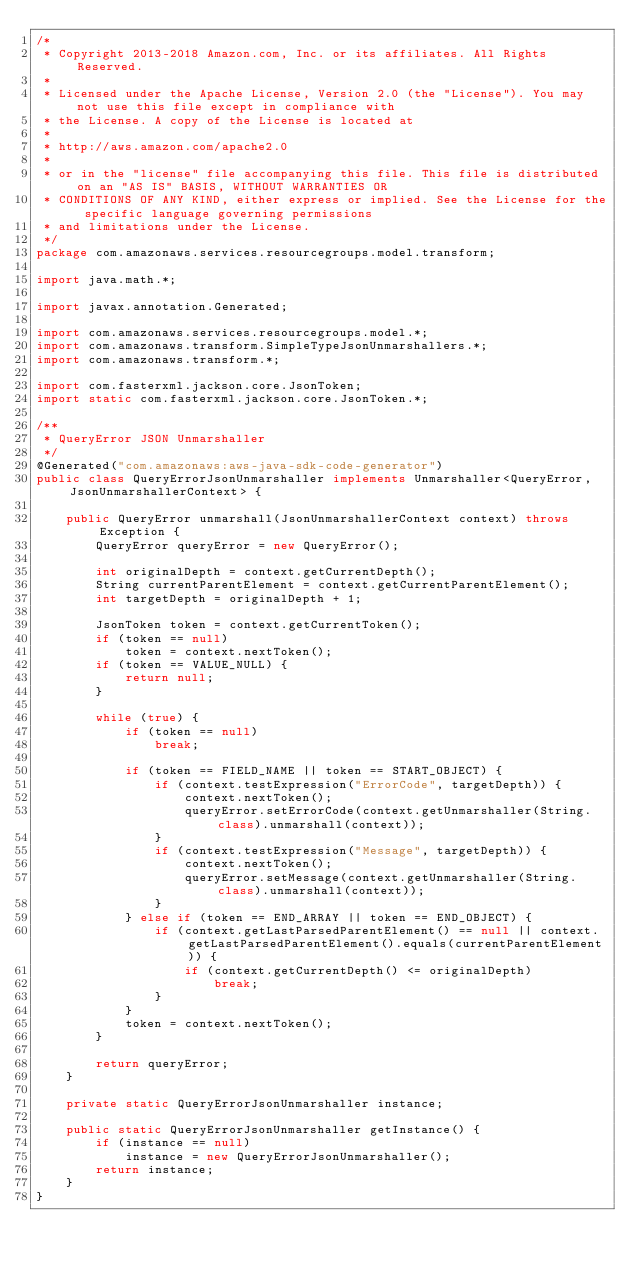Convert code to text. <code><loc_0><loc_0><loc_500><loc_500><_Java_>/*
 * Copyright 2013-2018 Amazon.com, Inc. or its affiliates. All Rights Reserved.
 * 
 * Licensed under the Apache License, Version 2.0 (the "License"). You may not use this file except in compliance with
 * the License. A copy of the License is located at
 * 
 * http://aws.amazon.com/apache2.0
 * 
 * or in the "license" file accompanying this file. This file is distributed on an "AS IS" BASIS, WITHOUT WARRANTIES OR
 * CONDITIONS OF ANY KIND, either express or implied. See the License for the specific language governing permissions
 * and limitations under the License.
 */
package com.amazonaws.services.resourcegroups.model.transform;

import java.math.*;

import javax.annotation.Generated;

import com.amazonaws.services.resourcegroups.model.*;
import com.amazonaws.transform.SimpleTypeJsonUnmarshallers.*;
import com.amazonaws.transform.*;

import com.fasterxml.jackson.core.JsonToken;
import static com.fasterxml.jackson.core.JsonToken.*;

/**
 * QueryError JSON Unmarshaller
 */
@Generated("com.amazonaws:aws-java-sdk-code-generator")
public class QueryErrorJsonUnmarshaller implements Unmarshaller<QueryError, JsonUnmarshallerContext> {

    public QueryError unmarshall(JsonUnmarshallerContext context) throws Exception {
        QueryError queryError = new QueryError();

        int originalDepth = context.getCurrentDepth();
        String currentParentElement = context.getCurrentParentElement();
        int targetDepth = originalDepth + 1;

        JsonToken token = context.getCurrentToken();
        if (token == null)
            token = context.nextToken();
        if (token == VALUE_NULL) {
            return null;
        }

        while (true) {
            if (token == null)
                break;

            if (token == FIELD_NAME || token == START_OBJECT) {
                if (context.testExpression("ErrorCode", targetDepth)) {
                    context.nextToken();
                    queryError.setErrorCode(context.getUnmarshaller(String.class).unmarshall(context));
                }
                if (context.testExpression("Message", targetDepth)) {
                    context.nextToken();
                    queryError.setMessage(context.getUnmarshaller(String.class).unmarshall(context));
                }
            } else if (token == END_ARRAY || token == END_OBJECT) {
                if (context.getLastParsedParentElement() == null || context.getLastParsedParentElement().equals(currentParentElement)) {
                    if (context.getCurrentDepth() <= originalDepth)
                        break;
                }
            }
            token = context.nextToken();
        }

        return queryError;
    }

    private static QueryErrorJsonUnmarshaller instance;

    public static QueryErrorJsonUnmarshaller getInstance() {
        if (instance == null)
            instance = new QueryErrorJsonUnmarshaller();
        return instance;
    }
}
</code> 